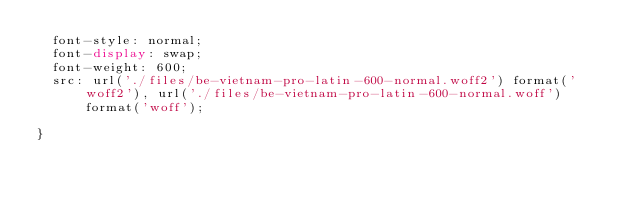<code> <loc_0><loc_0><loc_500><loc_500><_CSS_>  font-style: normal;
  font-display: swap;
  font-weight: 600;
  src: url('./files/be-vietnam-pro-latin-600-normal.woff2') format('woff2'), url('./files/be-vietnam-pro-latin-600-normal.woff') format('woff');
  
}
</code> 